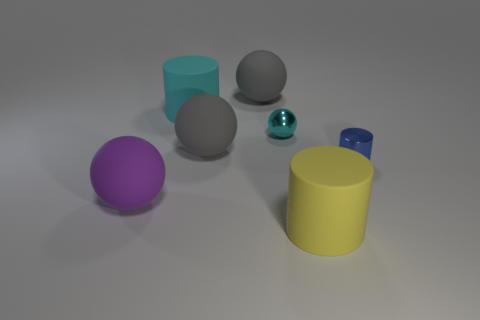Subtract 1 spheres. How many spheres are left? 3 Subtract all blue balls. Subtract all red cylinders. How many balls are left? 4 Add 3 cyan objects. How many objects exist? 10 Subtract all cylinders. How many objects are left? 4 Add 6 large cyan matte cylinders. How many large cyan matte cylinders exist? 7 Subtract 0 brown blocks. How many objects are left? 7 Subtract all blue cylinders. Subtract all gray things. How many objects are left? 4 Add 7 small metallic objects. How many small metallic objects are left? 9 